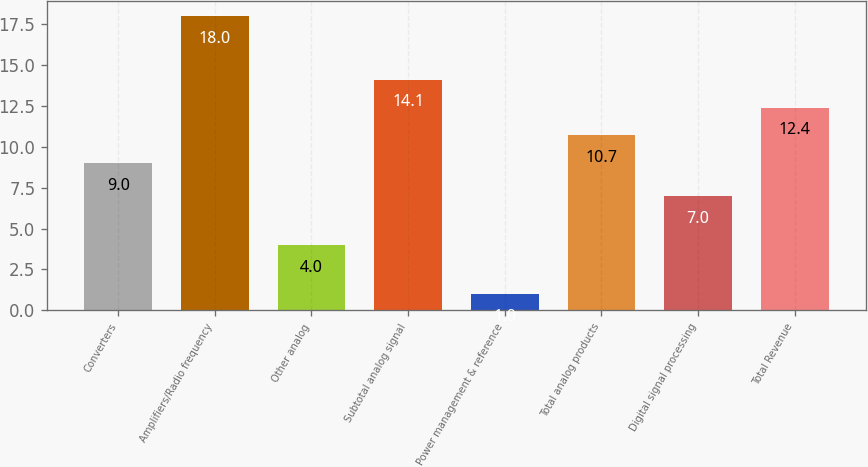Convert chart to OTSL. <chart><loc_0><loc_0><loc_500><loc_500><bar_chart><fcel>Converters<fcel>Amplifiers/Radio frequency<fcel>Other analog<fcel>Subtotal analog signal<fcel>Power management & reference<fcel>Total analog products<fcel>Digital signal processing<fcel>Total Revenue<nl><fcel>9<fcel>18<fcel>4<fcel>14.1<fcel>1<fcel>10.7<fcel>7<fcel>12.4<nl></chart> 